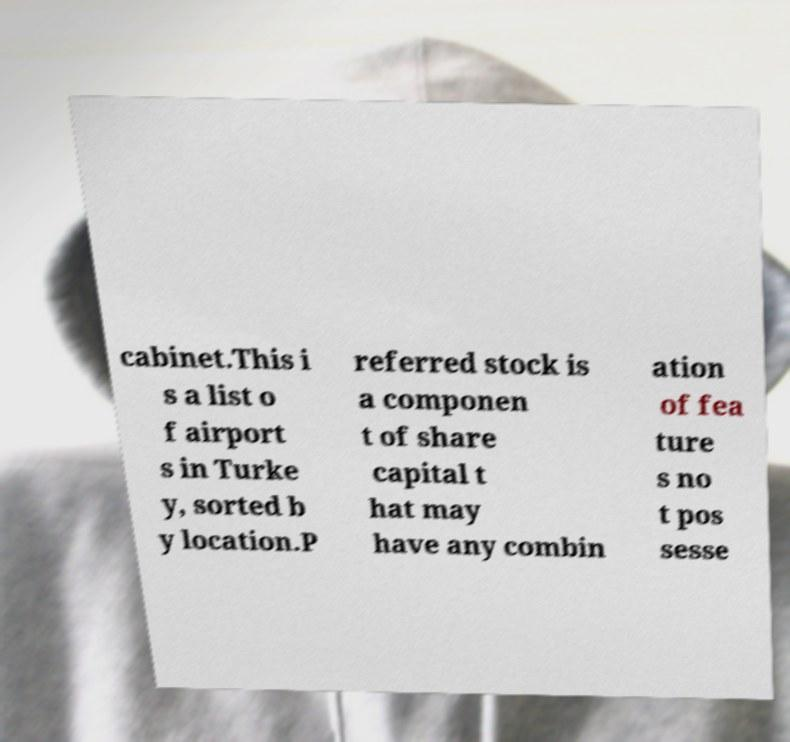Can you read and provide the text displayed in the image?This photo seems to have some interesting text. Can you extract and type it out for me? cabinet.This i s a list o f airport s in Turke y, sorted b y location.P referred stock is a componen t of share capital t hat may have any combin ation of fea ture s no t pos sesse 